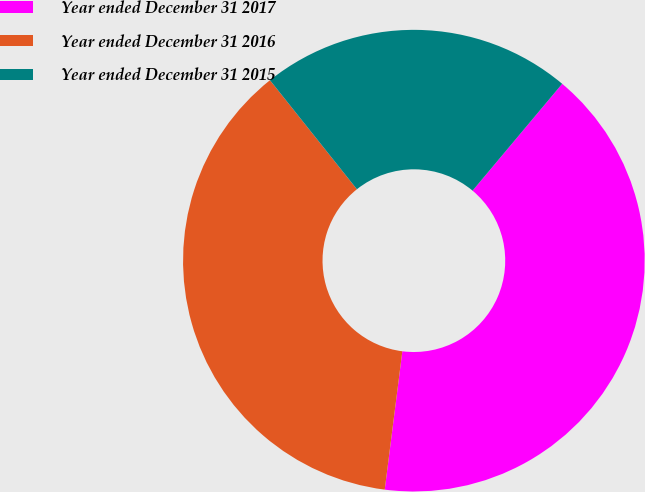Convert chart to OTSL. <chart><loc_0><loc_0><loc_500><loc_500><pie_chart><fcel>Year ended December 31 2017<fcel>Year ended December 31 2016<fcel>Year ended December 31 2015<nl><fcel>40.91%<fcel>37.27%<fcel>21.82%<nl></chart> 